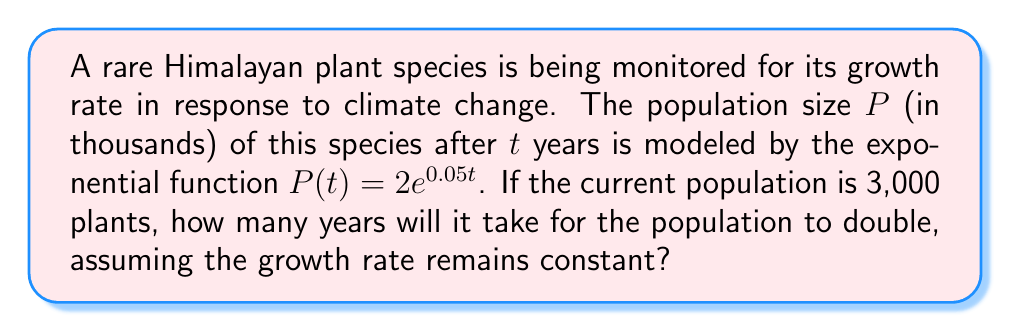Could you help me with this problem? To solve this problem, we'll use the properties of logarithms and the given exponential model.

1) The initial population is 3,000 plants, which is 3 thousand in our model.
   We need to find $t$ when $P(t) = 6$ (double the initial population).

2) Set up the equation:
   $$6 = 2e^{0.05t}$$

3) Divide both sides by 2:
   $$3 = e^{0.05t}$$

4) Take the natural logarithm of both sides:
   $$\ln(3) = \ln(e^{0.05t})$$

5) Using the logarithm property $\ln(e^x) = x$:
   $$\ln(3) = 0.05t$$

6) Solve for $t$:
   $$t = \frac{\ln(3)}{0.05}$$

7) Calculate the result:
   $$t \approx 21.97 \text{ years}$$

8) Round to the nearest year:
   $$t \approx 22 \text{ years}$$
Answer: 22 years 